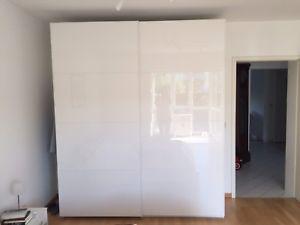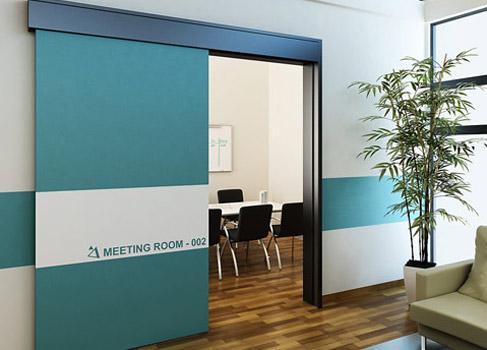The first image is the image on the left, the second image is the image on the right. Considering the images on both sides, is "One door is mirrored." valid? Answer yes or no. No. The first image is the image on the left, the second image is the image on the right. Evaluate the accuracy of this statement regarding the images: "There is a two door closet closed with the front being white with light line to create eight rectangles.". Is it true? Answer yes or no. Yes. 